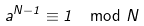Convert formula to latex. <formula><loc_0><loc_0><loc_500><loc_500>a ^ { N - 1 } \equiv 1 \mod N</formula> 